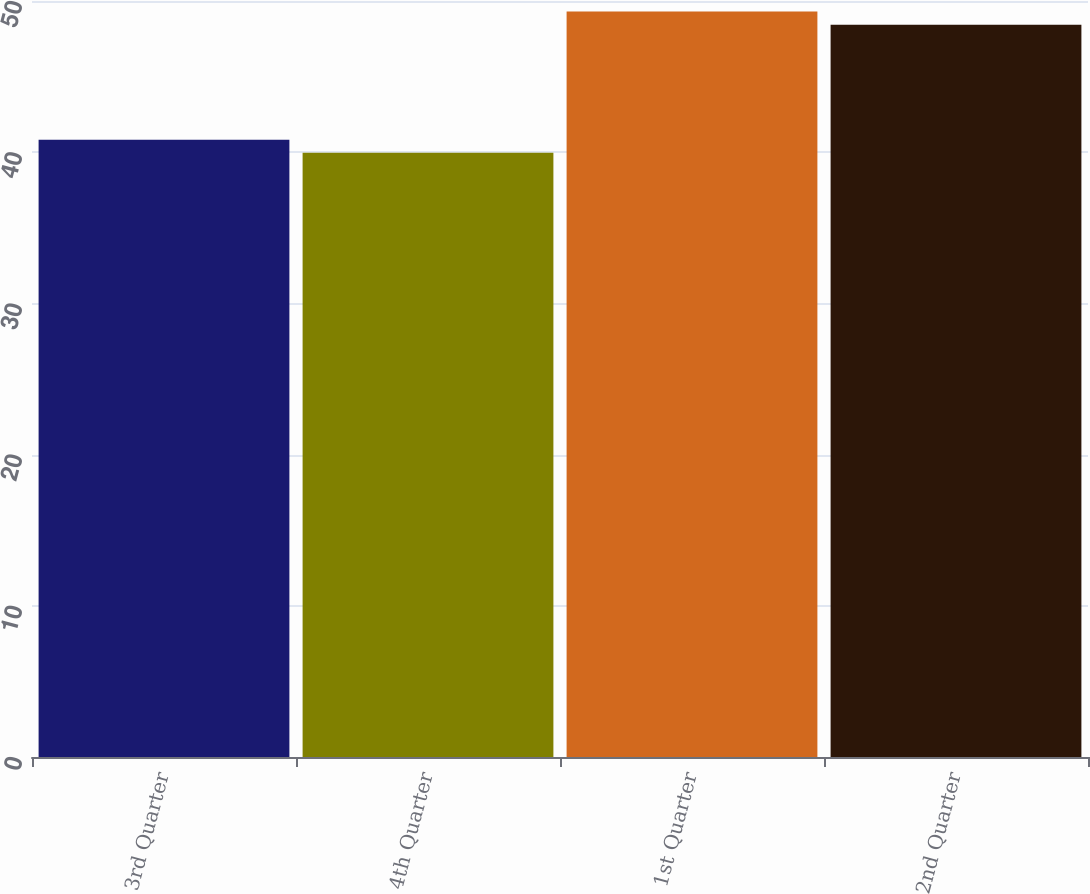Convert chart. <chart><loc_0><loc_0><loc_500><loc_500><bar_chart><fcel>3rd Quarter<fcel>4th Quarter<fcel>1st Quarter<fcel>2nd Quarter<nl><fcel>40.83<fcel>39.96<fcel>49.3<fcel>48.43<nl></chart> 